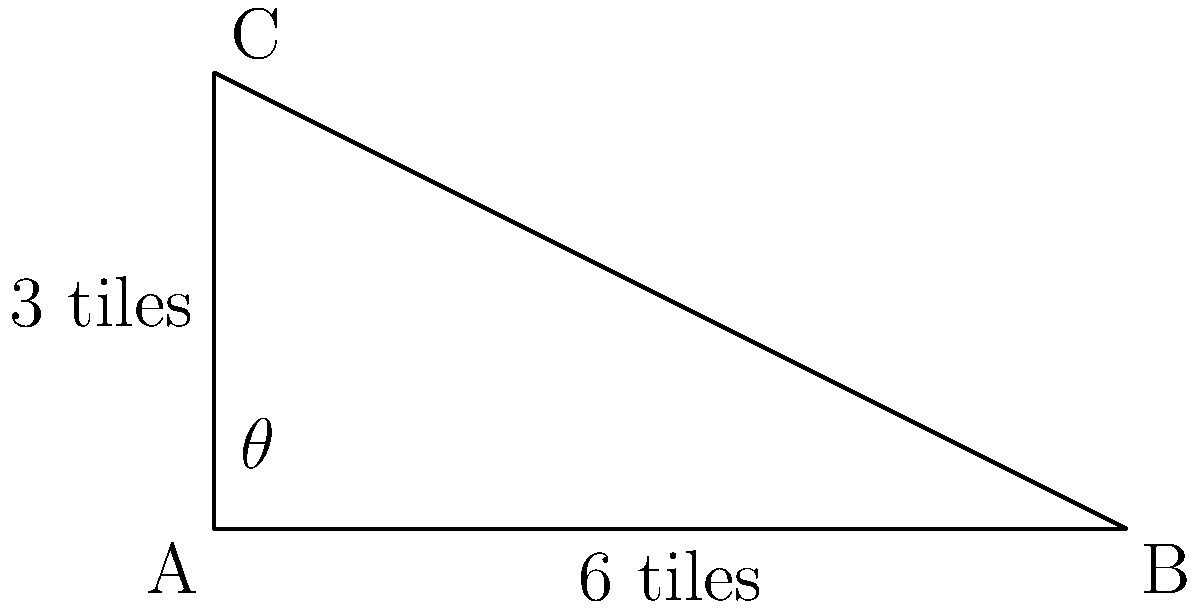In Fortnite, you're building a ramp that spans 6 tiles horizontally and rises 3 tiles vertically. What is the angle $\theta$ of the ramp with respect to the ground? To find the angle $\theta$ of the ramp, we can use the trigonometric function tangent (tan). In a right triangle:

1) $\tan \theta = \frac{\text{opposite}}{\text{adjacent}}$

2) In this case:
   - Opposite side (rise) = 3 tiles
   - Adjacent side (run) = 6 tiles

3) Substituting these values:
   $\tan \theta = \frac{3}{6} = \frac{1}{2}$

4) To find $\theta$, we need to use the inverse tangent function (arctan or $\tan^{-1}$):
   $\theta = \tan^{-1}(\frac{1}{2})$

5) Using a calculator or trigonometric tables:
   $\theta \approx 26.57°$

6) Round to the nearest degree:
   $\theta \approx 27°$
Answer: $27°$ 